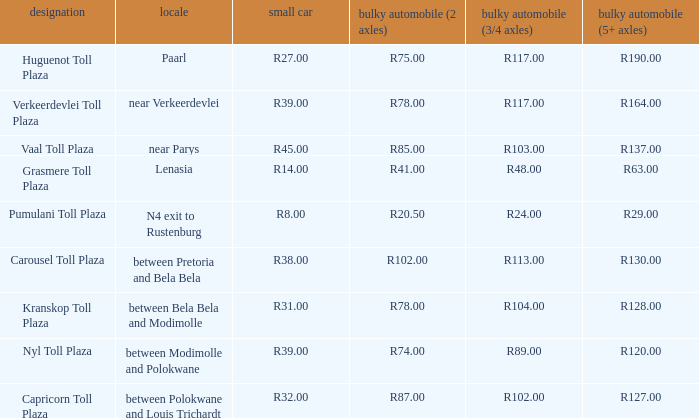What is the toll for heavy vehicles with 3/4 axles at Verkeerdevlei toll plaza? R117.00. Could you parse the entire table? {'header': ['designation', 'locale', 'small car', 'bulky automobile (2 axles)', 'bulky automobile (3/4 axles)', 'bulky automobile (5+ axles)'], 'rows': [['Huguenot Toll Plaza', 'Paarl', 'R27.00', 'R75.00', 'R117.00', 'R190.00'], ['Verkeerdevlei Toll Plaza', 'near Verkeerdevlei', 'R39.00', 'R78.00', 'R117.00', 'R164.00'], ['Vaal Toll Plaza', 'near Parys', 'R45.00', 'R85.00', 'R103.00', 'R137.00'], ['Grasmere Toll Plaza', 'Lenasia', 'R14.00', 'R41.00', 'R48.00', 'R63.00'], ['Pumulani Toll Plaza', 'N4 exit to Rustenburg', 'R8.00', 'R20.50', 'R24.00', 'R29.00'], ['Carousel Toll Plaza', 'between Pretoria and Bela Bela', 'R38.00', 'R102.00', 'R113.00', 'R130.00'], ['Kranskop Toll Plaza', 'between Bela Bela and Modimolle', 'R31.00', 'R78.00', 'R104.00', 'R128.00'], ['Nyl Toll Plaza', 'between Modimolle and Polokwane', 'R39.00', 'R74.00', 'R89.00', 'R120.00'], ['Capricorn Toll Plaza', 'between Polokwane and Louis Trichardt', 'R32.00', 'R87.00', 'R102.00', 'R127.00']]} 